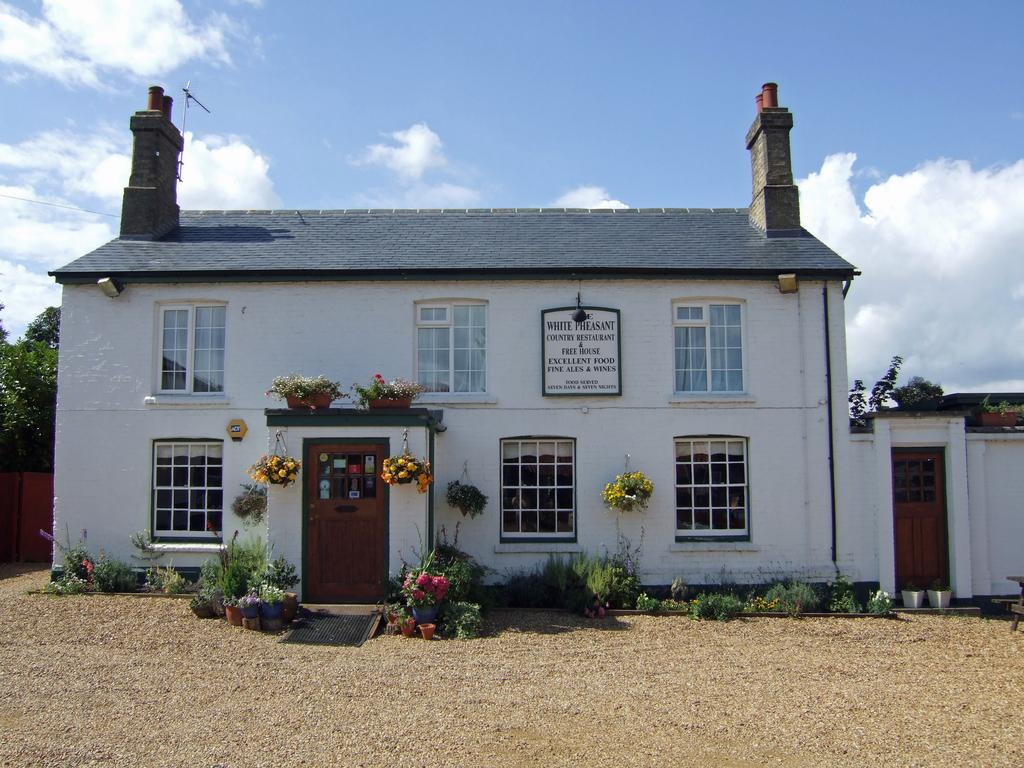What is the main subject in the middle of the picture? There is a building in the middle of the picture. What can be seen in front of the building? There are plants in front of the building. What is visible in the sky in the background of the image? There are clouds visible in the sky in the background of the image. What type of noise can be heard coming from the basketball game in the image? There is no basketball game present in the image, so no noise can be heard from it. 